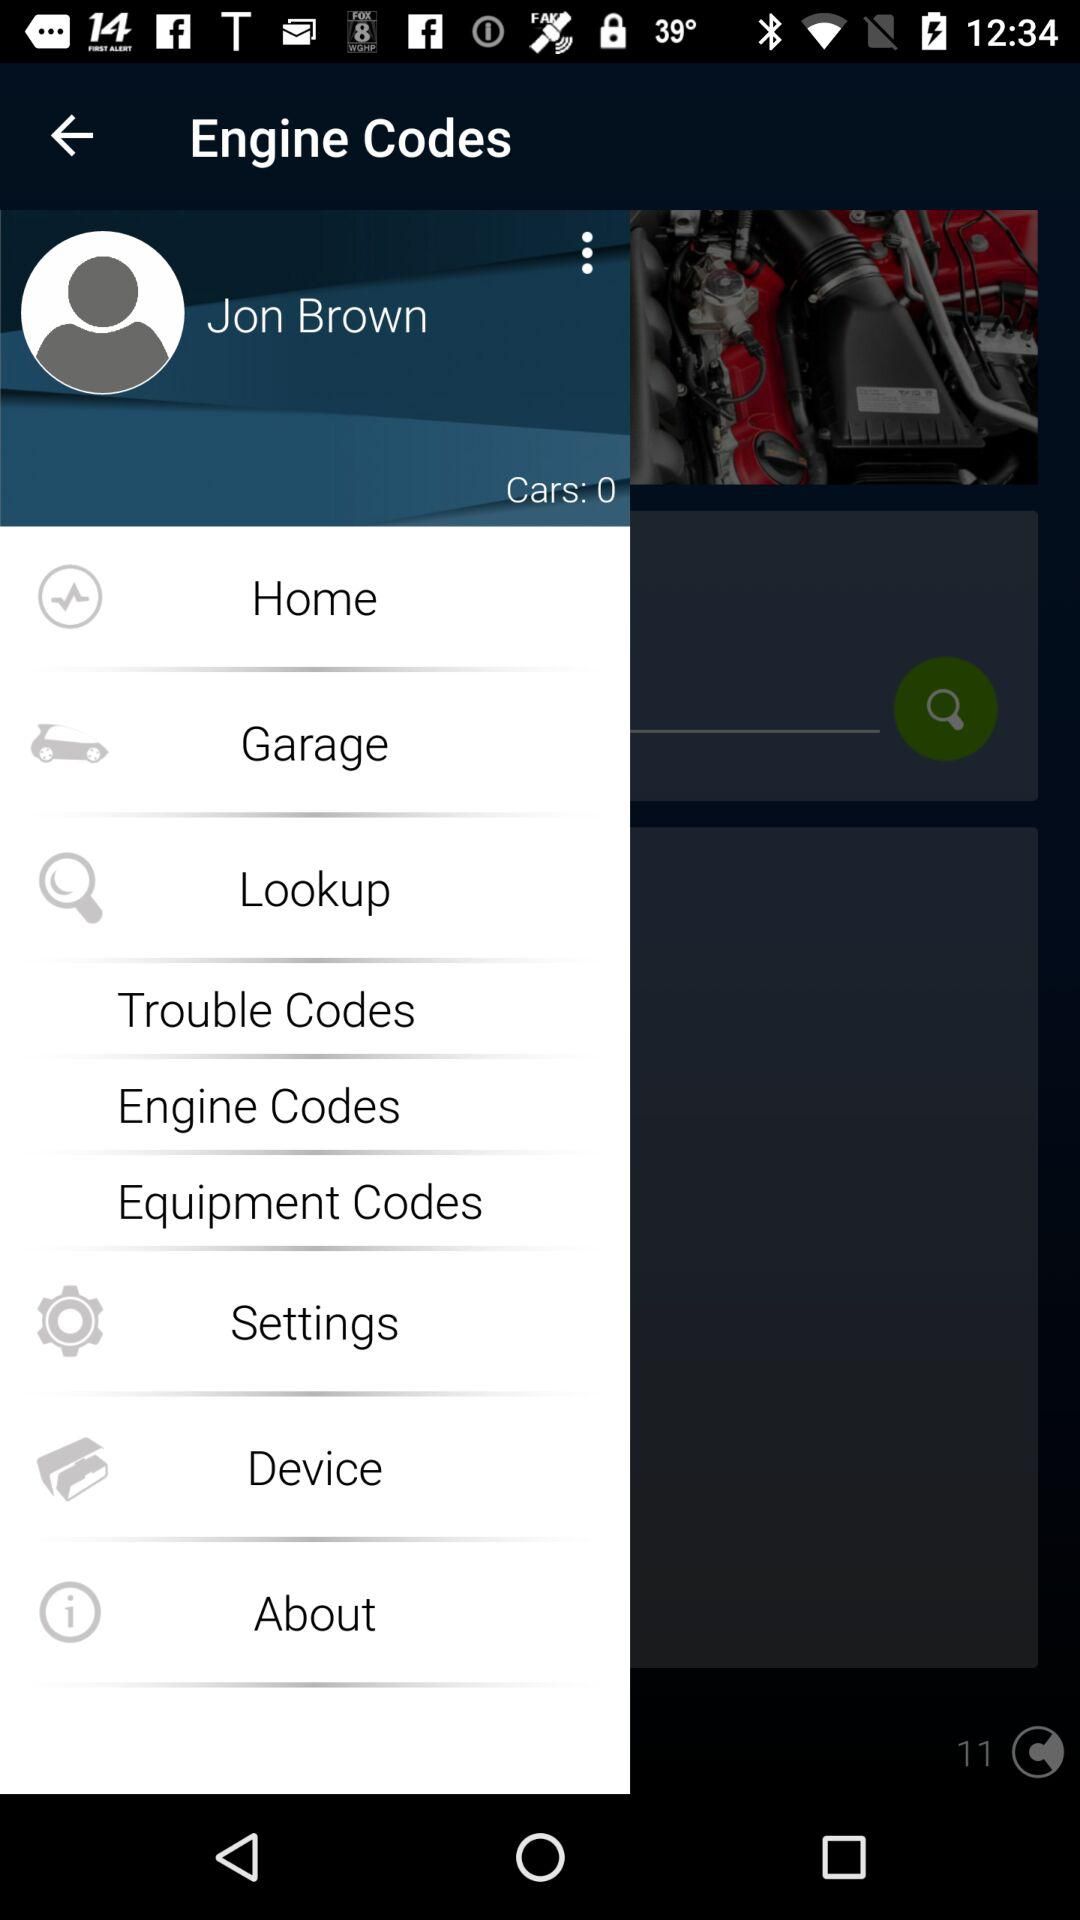How many users are online?
When the provided information is insufficient, respond with <no answer>. <no answer> 